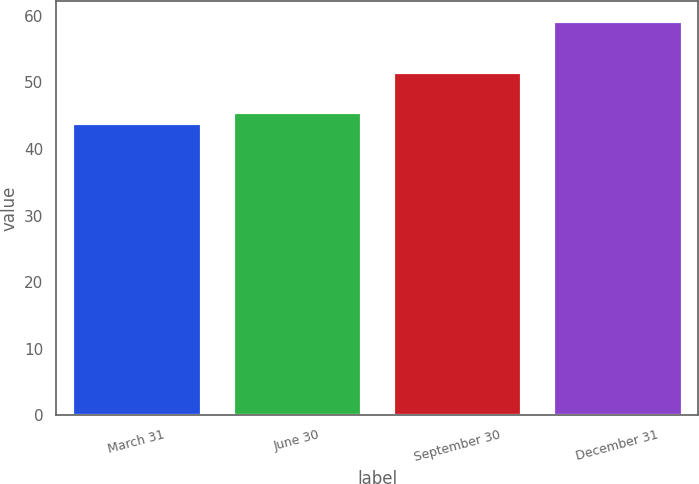Convert chart to OTSL. <chart><loc_0><loc_0><loc_500><loc_500><bar_chart><fcel>March 31<fcel>June 30<fcel>September 30<fcel>December 31<nl><fcel>43.96<fcel>45.58<fcel>51.6<fcel>59.28<nl></chart> 